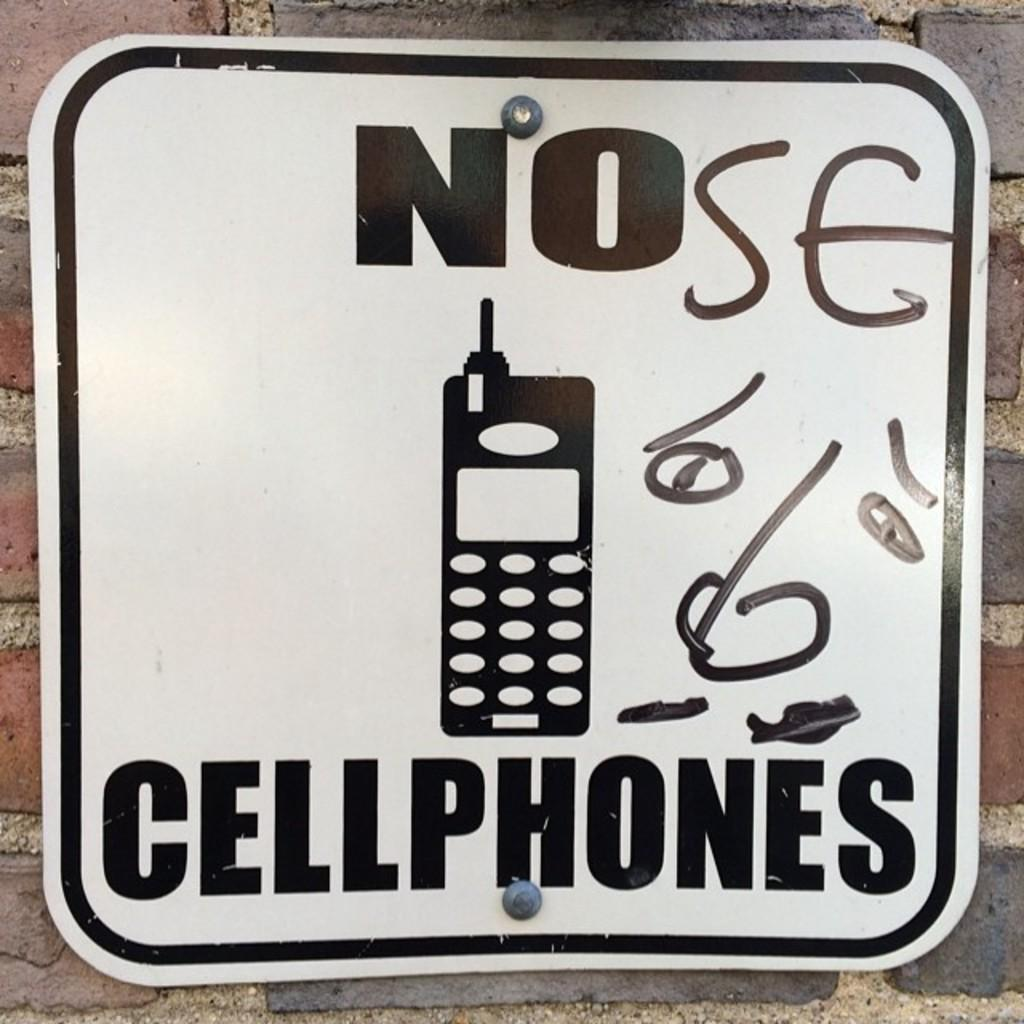Provide a one-sentence caption for the provided image. someone deface a No cellphones sign to say NOse. 